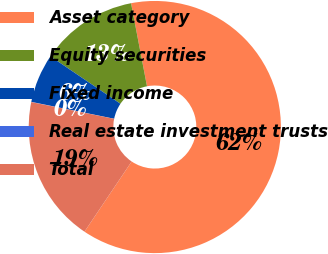Convert chart to OTSL. <chart><loc_0><loc_0><loc_500><loc_500><pie_chart><fcel>Asset category<fcel>Equity securities<fcel>Fixed income<fcel>Real estate investment trusts<fcel>Total<nl><fcel>62.43%<fcel>12.51%<fcel>6.27%<fcel>0.03%<fcel>18.75%<nl></chart> 